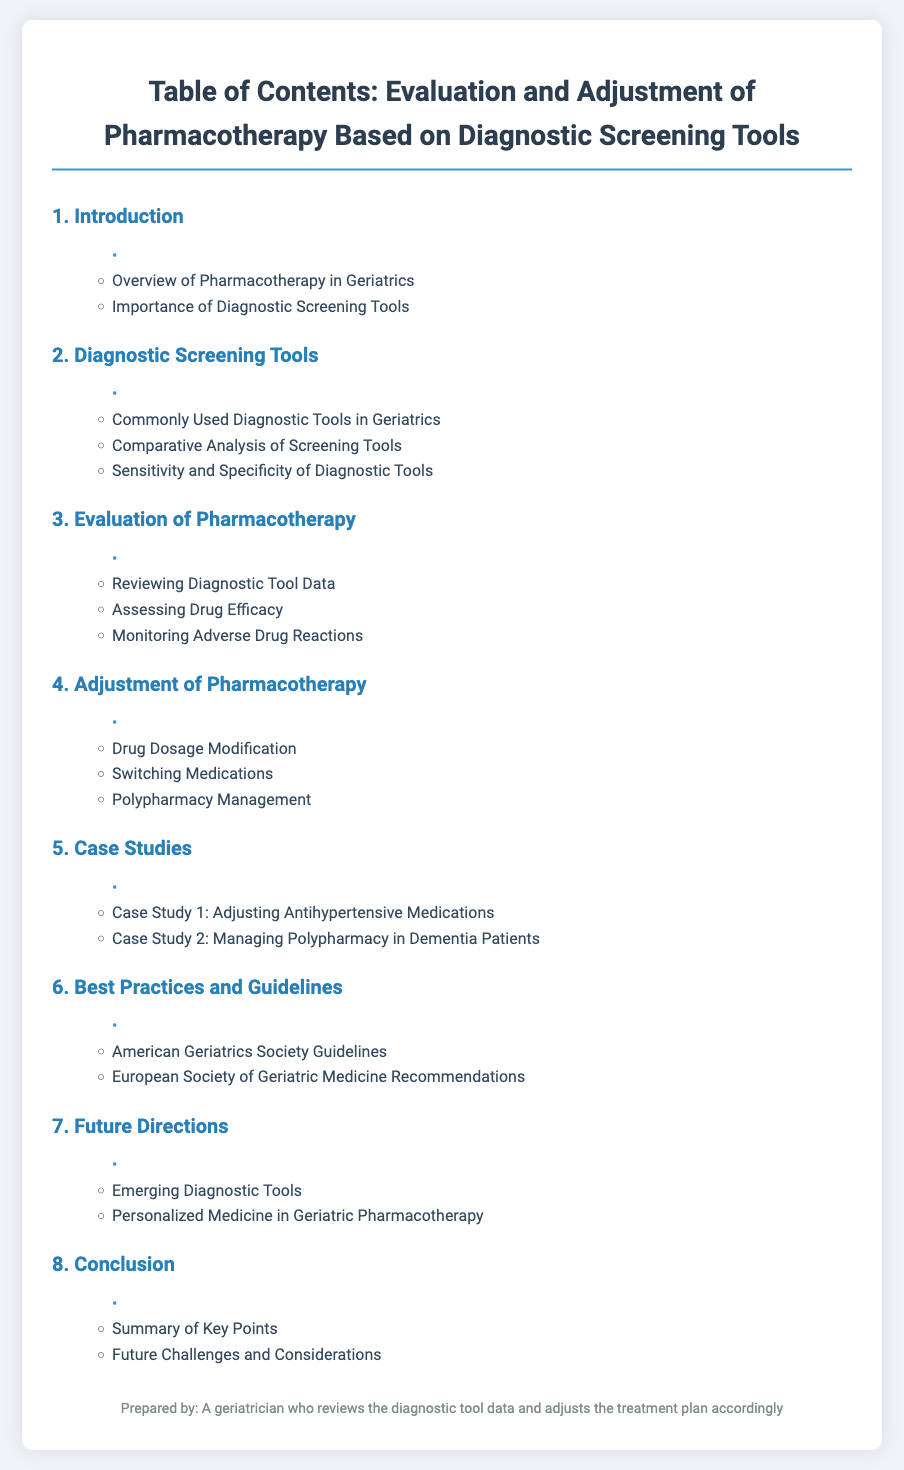What is the title of the document? The title is stated at the top of the document as the subject of the table of contents.
Answer: Evaluation and Adjustment of Pharmacotherapy Based on Diagnostic Screening Tools How many sections are there in the table of contents? The sections are numbered at the beginning of each section in the list.
Answer: 8 What is the first subsection under "Diagnostic Screening Tools"? The first subsection is mentioned after the title of the main section, indicating its order.
Answer: Commonly Used Diagnostic Tools in Geriatrics What case study is related to antihypertensive medications? The specific case study is listed under the "Case Studies" section along with its number.
Answer: Case Study 1: Adjusting Antihypertensive Medications Which guidelines are mentioned under "Best Practices and Guidelines"? The section lists the guidelines without elaboration; they are specifically named as per the content.
Answer: American Geriatrics Society Guidelines, European Society of Geriatric Medicine Recommendations What is the last subsection in the document? The last subsection appears after the conclusion and summarizes the contents of the document.
Answer: Future Challenges and Considerations How many case studies are included in the document? The case studies are explicitly numbered in the relevant section of the table of contents.
Answer: 2 What topic is covered in section 7? The document indicates that each section title provides insight into the subject matter covered therein.
Answer: Future Directions 